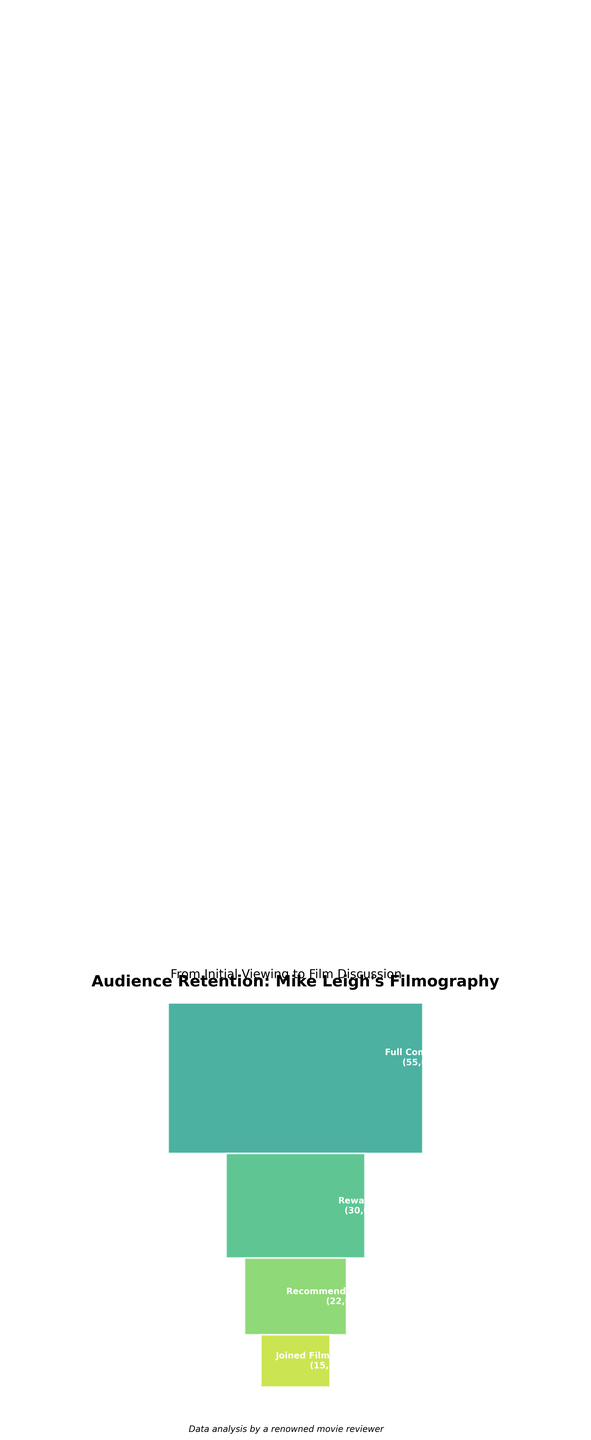What's the title of the figure? The title is located at the top of the figure as a major heading. It clearly informs viewers about the content of the figure.
Answer: Audience Retention: Mike Leigh's Filmography How many stages are there in the funnel chart? The stages are labeled on the segments of the funnel. By counting these labels, we can determine the number of stages.
Answer: 7 Which stage has the highest number of viewers? By looking at the height of each stage segment, we can identify which one has the highest value. The funnel begins with the stage that has the most viewers.
Answer: Initial Viewing What is the difference in the number of viewers between the Midpoint and Full Completion stages? Subtract the number of viewers at the Full Completion stage from those at the Midpoint stage to find the difference.
Answer: 17,000 Which stage reflects a significant drop in viewers? By comparing the heights of each segment, we can see where there is a steep decline in the number of viewers.
Answer: Rewatched How many viewers completed up to three-quarters of the films? Find the value corresponding to the Three-Quarter Mark stage to determine the number of viewers at this point.
Answer: 63,000 What is the ratio of viewers who recommended the film to those who joined film discussions? Divide the number of viewers who recommended the film by the number of those who joined discussions.
Answer: 1.47 Compare the number of viewers who watched the first 30 minutes to those who reached the midpoint. Look at the values for the First 30 Minutes and Midpoint stages, then subtract the second value from the first to compare.
Answer: 13,000 Which stage shows the smallest number of viewers? By observing the segment with the least height, we can find the stage with the smallest number of viewers.
Answer: Joined Film Discussion Calculate the percentage of viewers who rewatched the films out of those who initially viewed them. Divide the number of viewers who rewatched by the number of initial viewers, then multiply by 100 to find the percentage.
Answer: 30% 